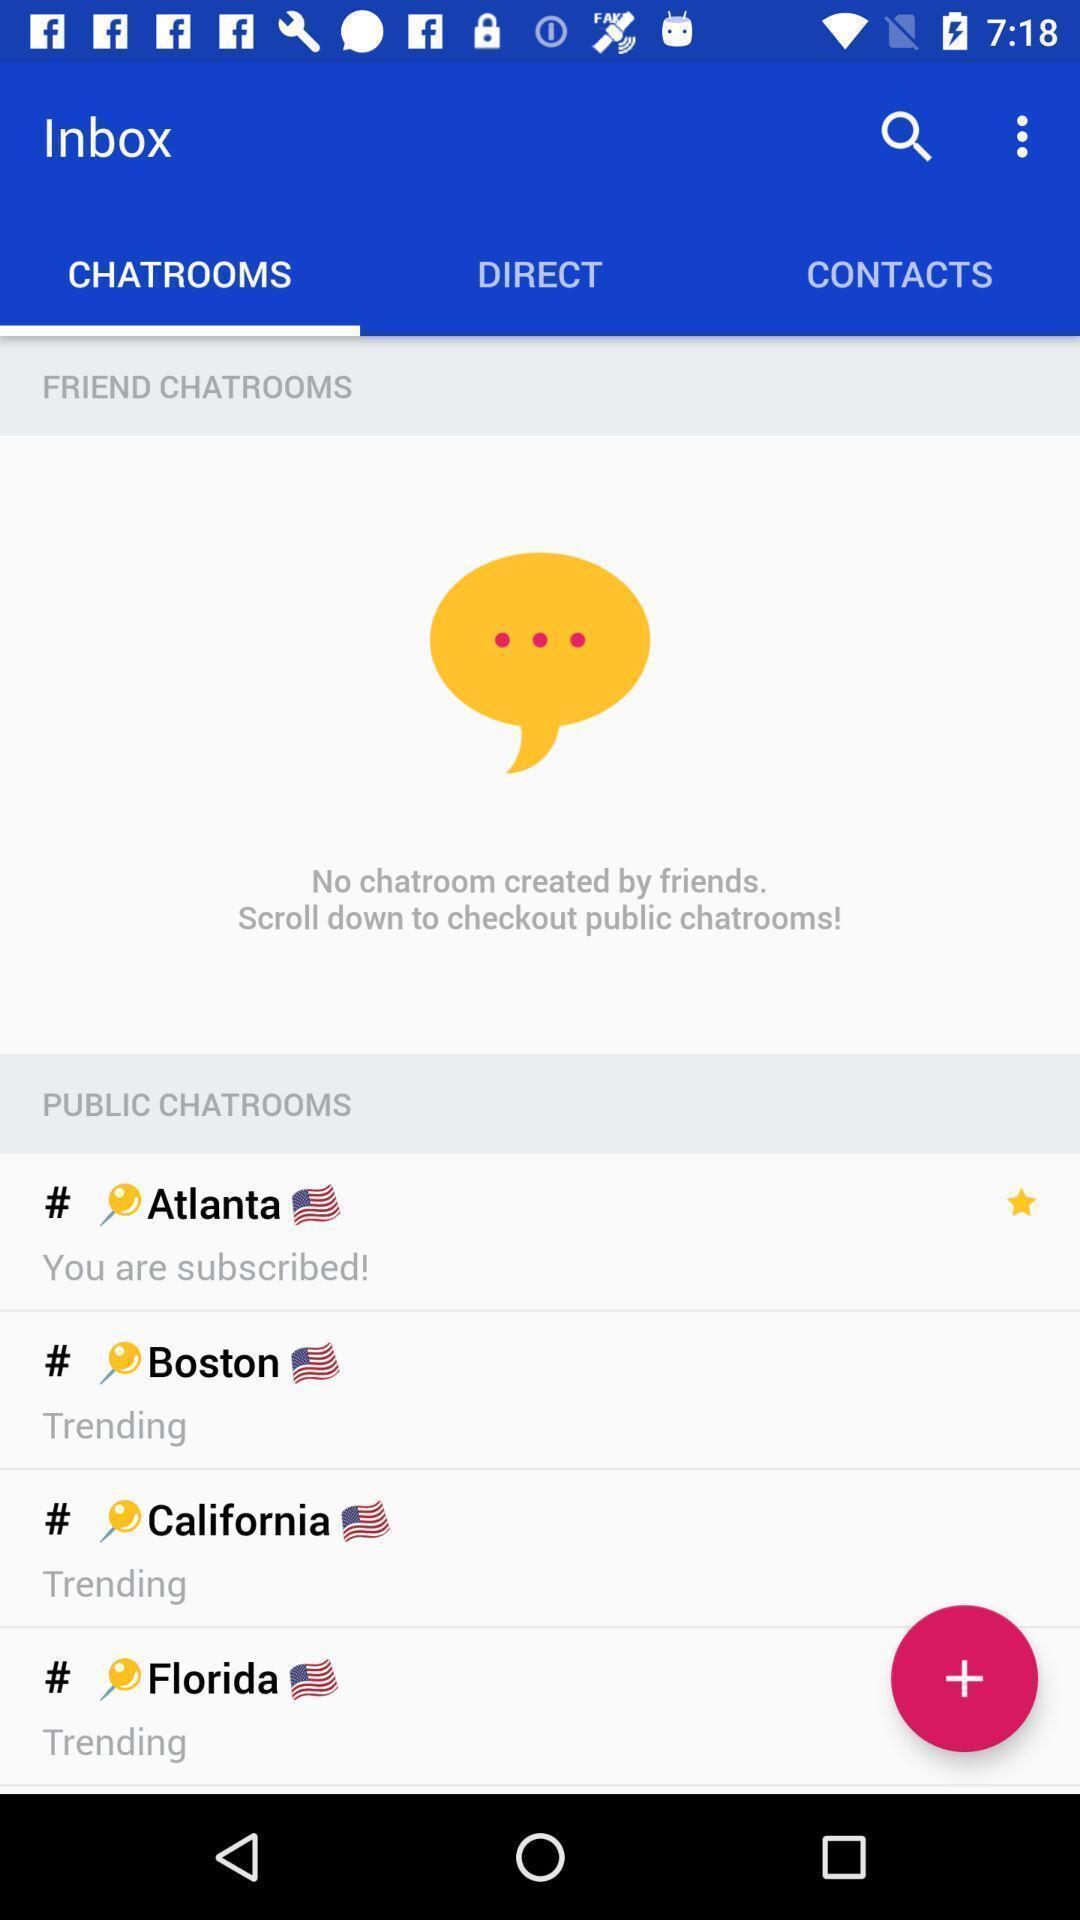Tell me what you see in this picture. Screen showing options in chatrooms page. 